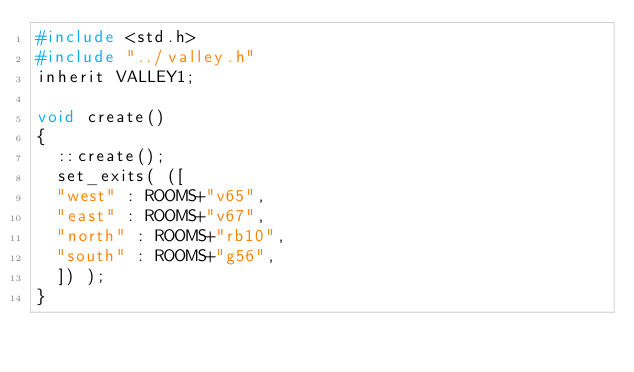Convert code to text. <code><loc_0><loc_0><loc_500><loc_500><_C_>#include <std.h>
#include "../valley.h"
inherit VALLEY1;

void create()
{
	::create();
	set_exits( ([
	"west" : ROOMS+"v65",
	"east" : ROOMS+"v67",
	"north" : ROOMS+"rb10",
	"south" : ROOMS+"g56",
	]) );
}
</code> 